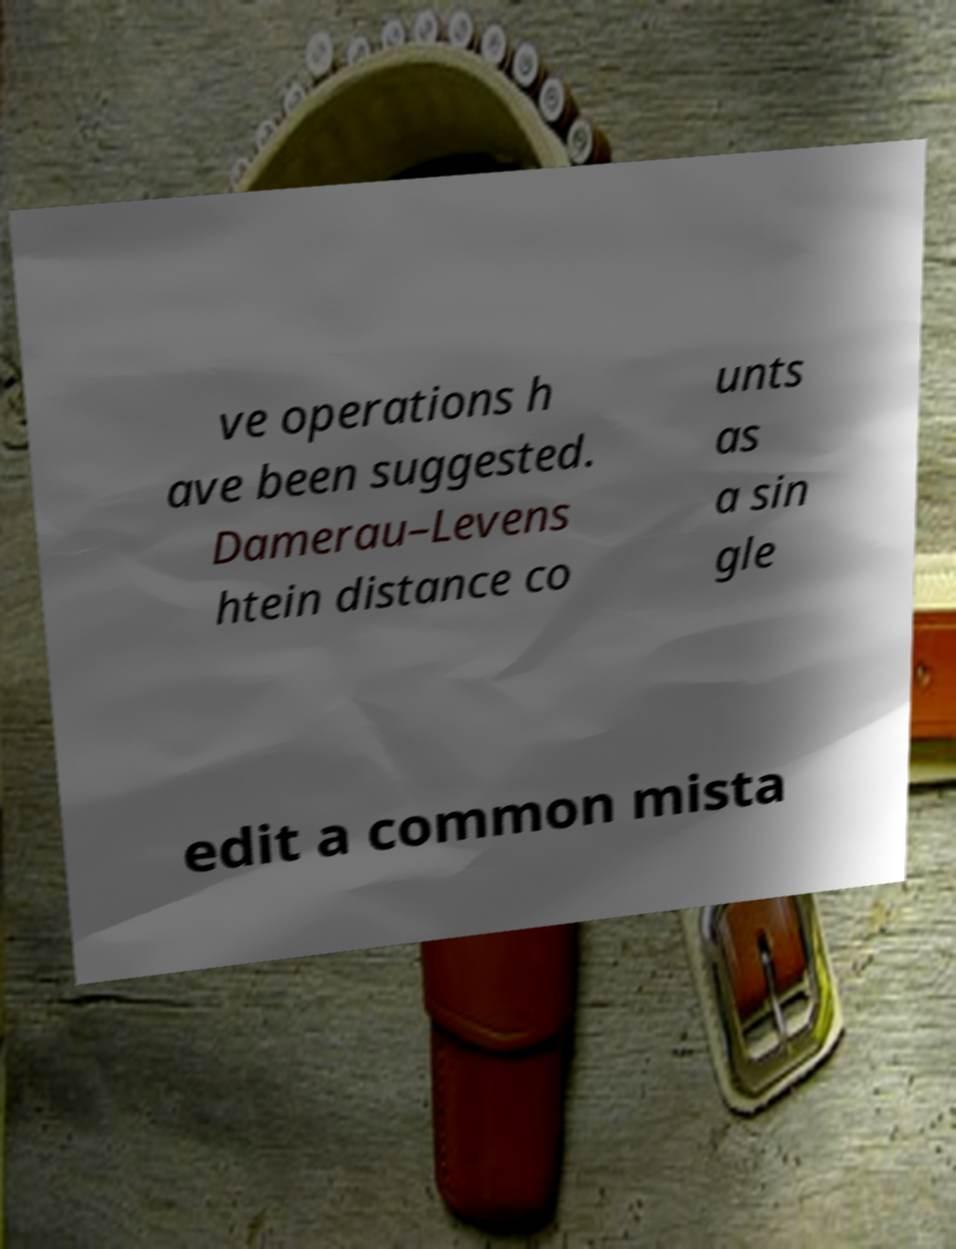Can you read and provide the text displayed in the image?This photo seems to have some interesting text. Can you extract and type it out for me? ve operations h ave been suggested. Damerau–Levens htein distance co unts as a sin gle edit a common mista 